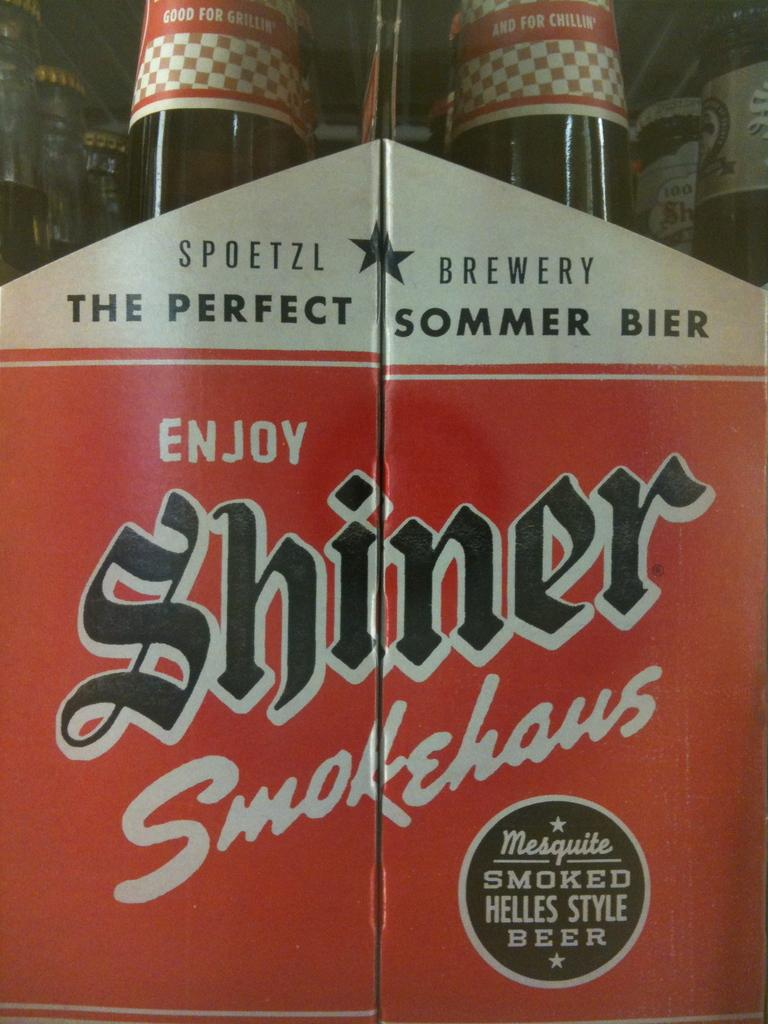<image>
Describe the image concisely. a box of the perfect sommer bier that says 'enjoy shiner smokehaus' 